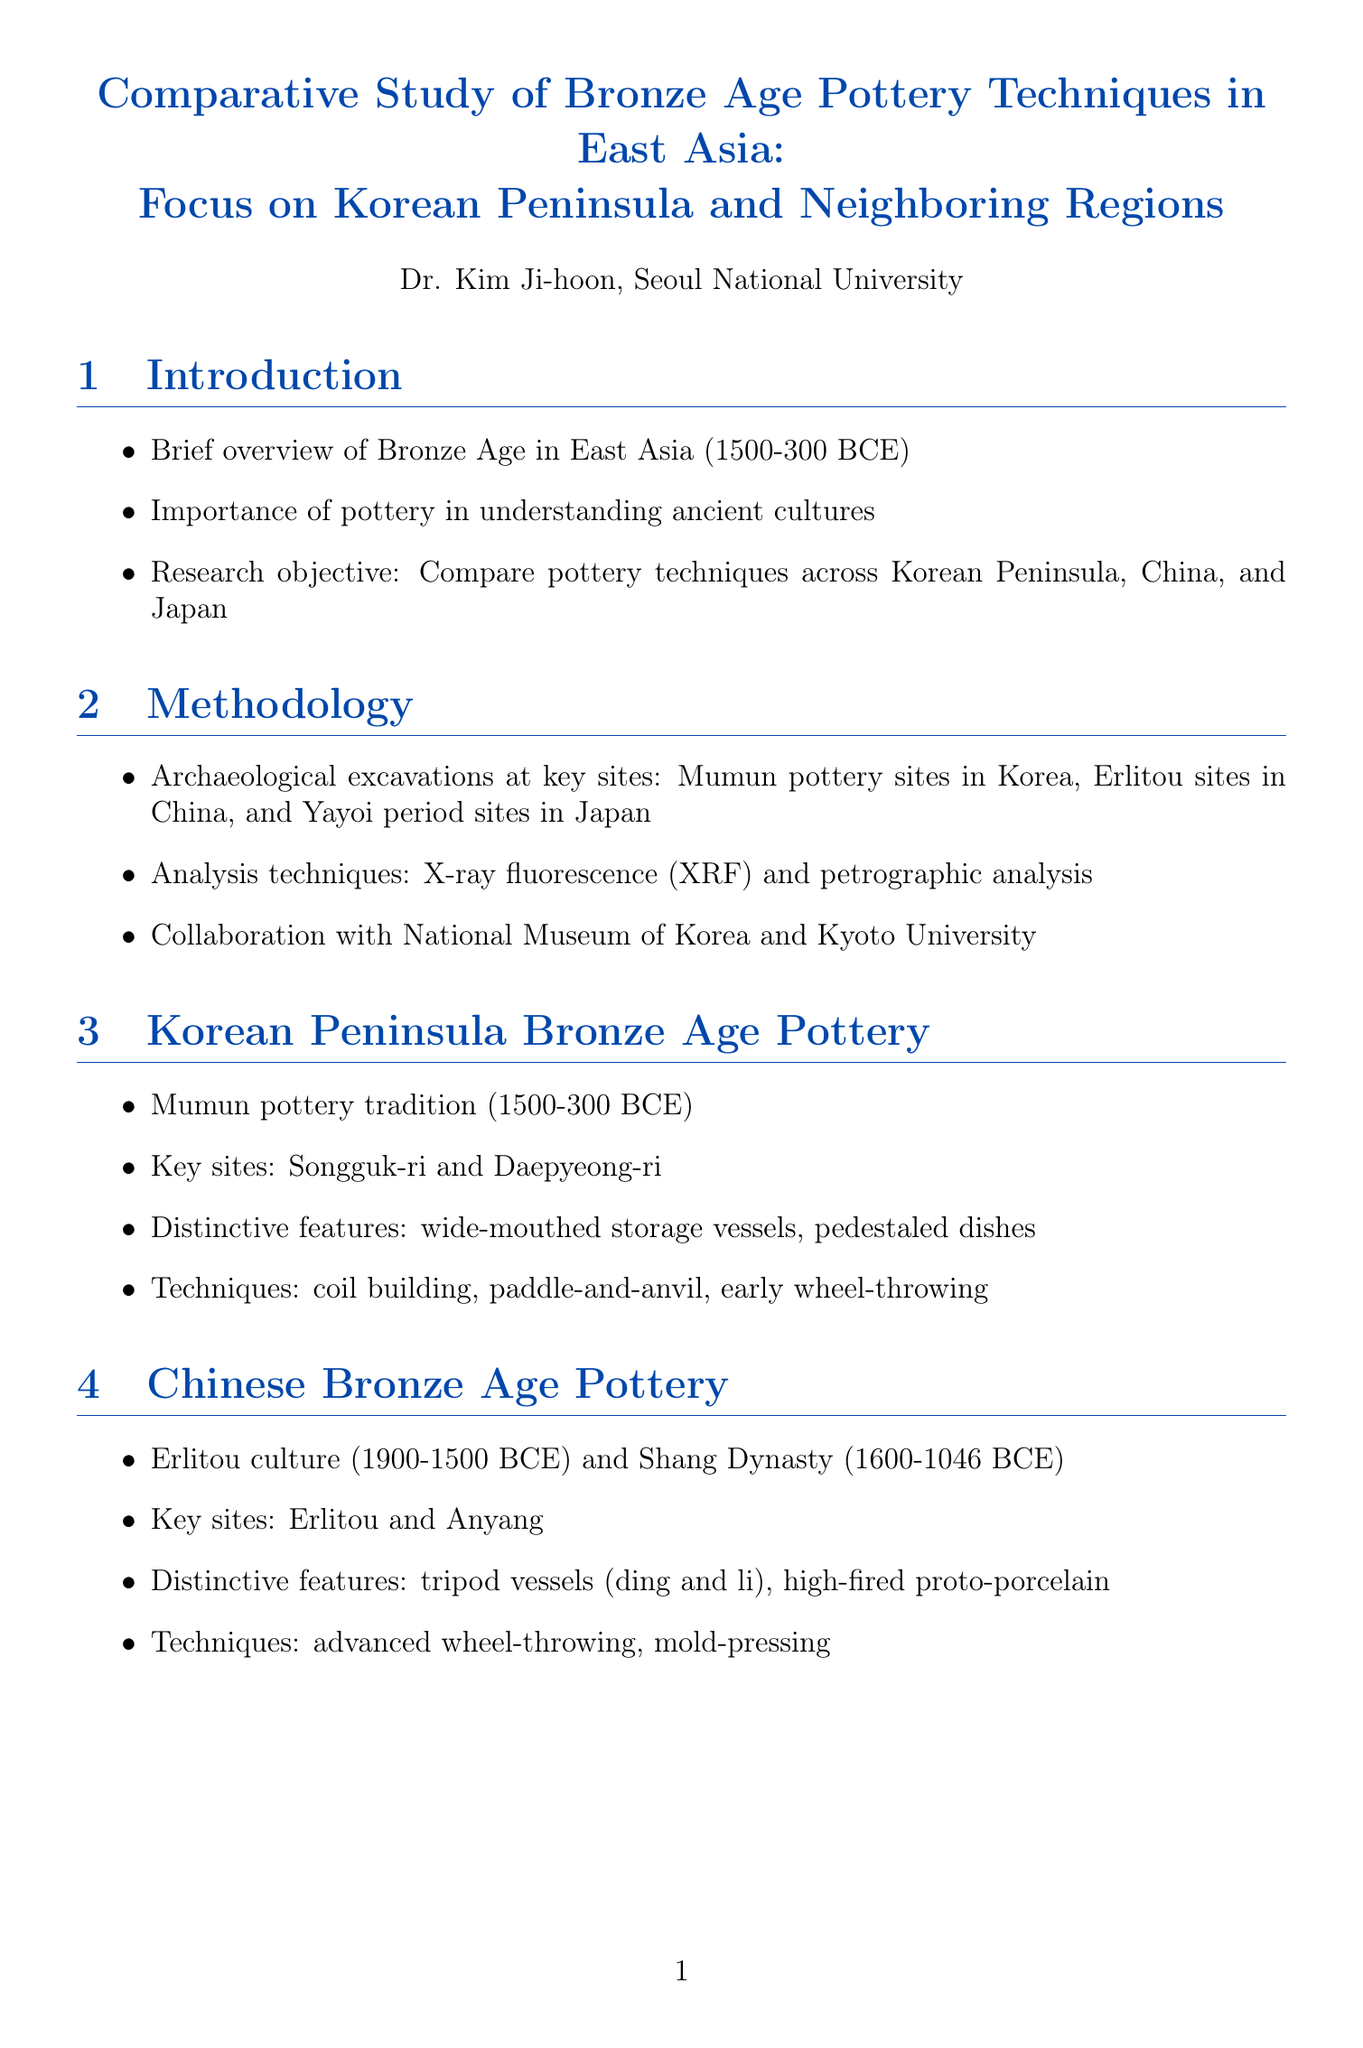What is the focus of the report? The focus of the report is on the study of pottery techniques during the Bronze Age in East Asia, specifically on the Korean Peninsula and neighboring regions.
Answer: Bronze Age pottery techniques in East Asia: Focus on Korean Peninsula and Neighboring Regions Who is the author of the report? The report is authored by Dr. Kim Ji-hoon from Seoul National University.
Answer: Dr. Kim Ji-hoon What is the timeframe of the Bronze Age discussed in the report? The Bronze Age in East Asia is discussed in the timeframe of 1500-300 BCE.
Answer: 1500-300 BCE What technique is mentioned as being used for analyzing pottery? One of the analysis techniques mentioned is X-ray fluorescence (XRF).
Answer: X-ray fluorescence (XRF) Which sites were key for the Korean Peninsula Bronze Age pottery study? The key sites for the Korean Peninsula study are Songguk-ri and Daepyeong-ri.
Answer: Songguk-ri and Daepyeong-ri What is a distinctive feature of Chinese Bronze Age pottery? A distinctive feature of Chinese Bronze Age pottery is tripod vessels (ding and li).
Answer: tripod vessels (ding and li) What kind of decorative styles are unique to Korea? The unique decorative styles mentioned for Korea are incised designs.
Answer: Korean incised designs What were the socio-cultural implications of pottery in the report? Pottery serves as an indicator of social stratification according to the report.
Answer: indicator of social stratification What future research direction is suggested in the report? The future research direction suggested is the need for more comprehensive dating and chemical analysis.
Answer: more comprehensive dating and chemical analysis 